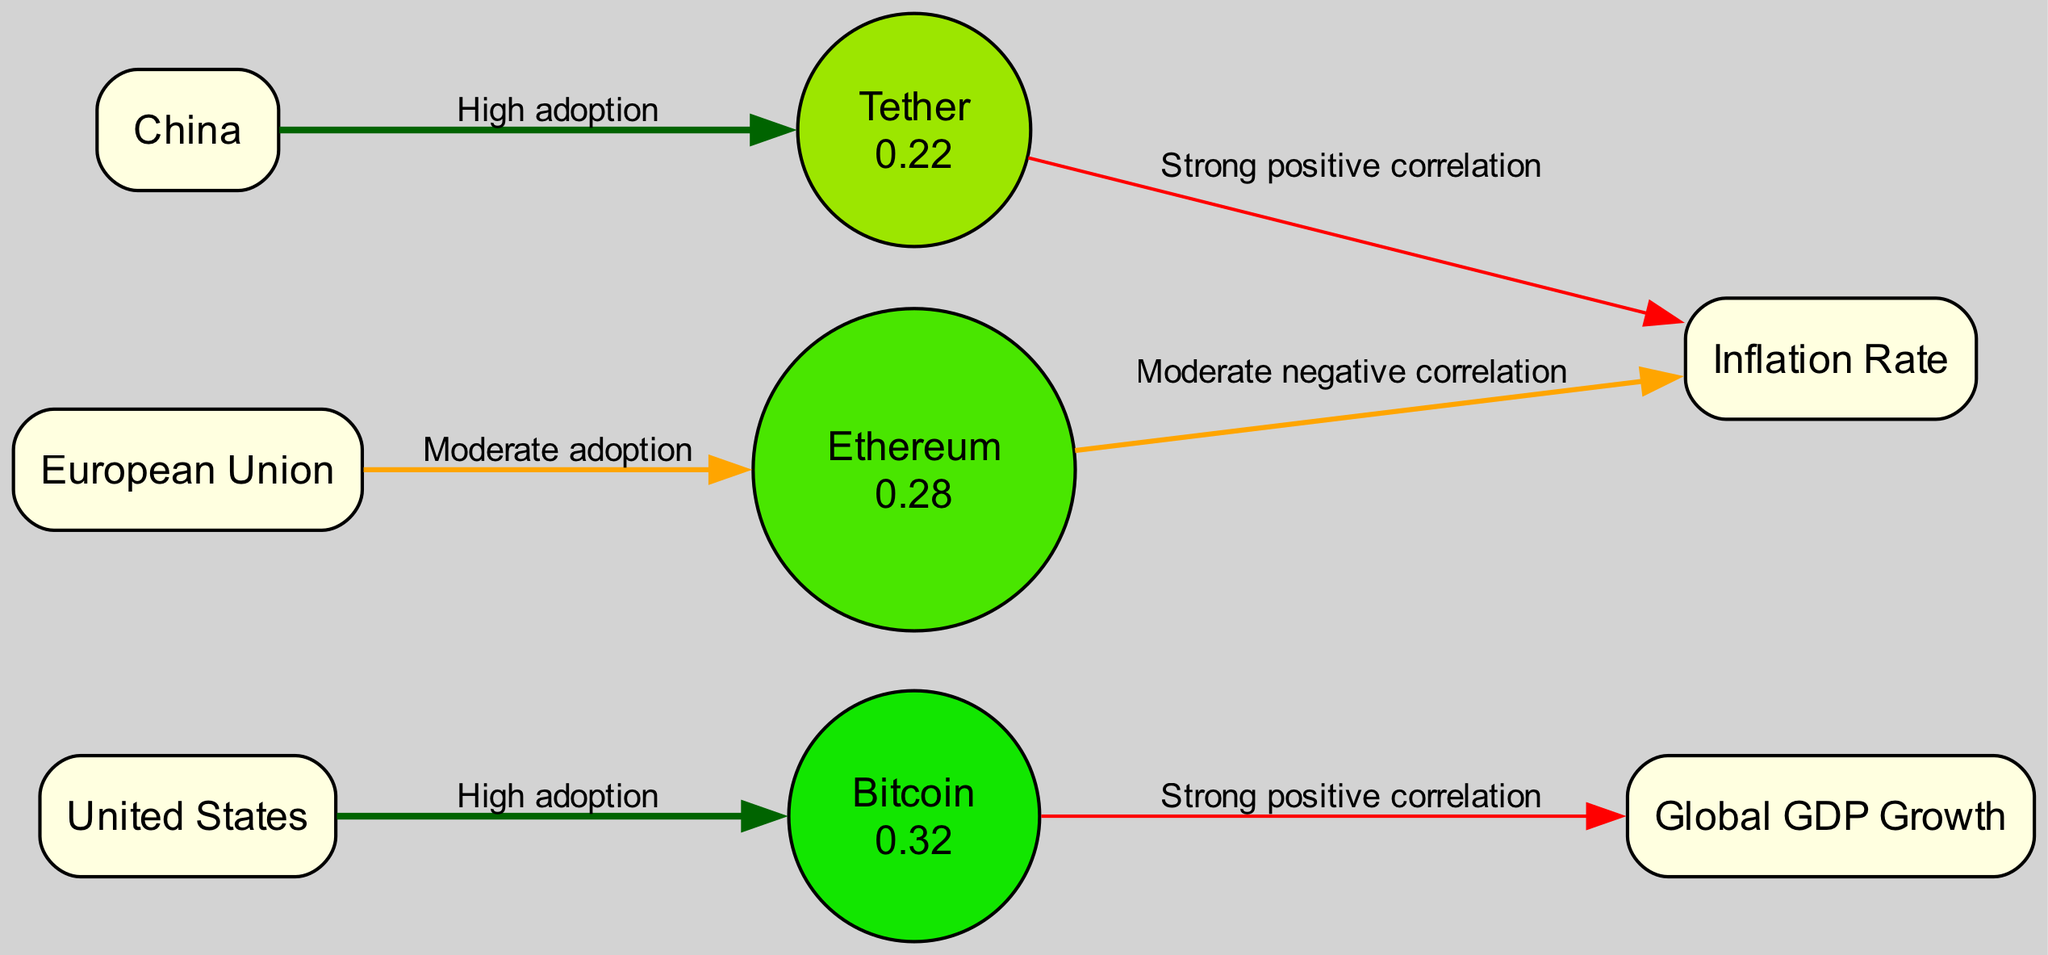What is the adoption rate of Bitcoin? The adoption rate for Bitcoin is specified in the node labeled "Bitcoin," which is 0.32.
Answer: 0.32 How many nodes are present in the diagram? By counting the nodes listed in the data, there are a total of 8 nodes: Bitcoin, Ethereum, Tether, Global GDP Growth, Inflation Rate, United States, China, and European Union.
Answer: 8 What type of correlation exists between Bitcoin and Global GDP Growth? The edge from Bitcoin to Global GDP Growth is labeled "Strong positive correlation," indicating a strong relationship in terms of correlation.
Answer: Strong positive correlation Which country shows high adoption of Tether? The edge from China to Tether indicates that China has a high adoption of Tether as it directly connects these two nodes with the specified relationship.
Answer: China What is the correlation type between Ethereum and Inflation Rate? The edge between Ethereum and Inflation Rate is labeled "Moderate negative correlation," which indicates the nature of their relationship in the context of the diagram.
Answer: Moderate negative correlation What color represents nodes with a high adoption rate in the diagram? High adoption rate nodes are represented in dark green due to their specified color coding as per the edges indicating their level of adoption.
Answer: Dark green Which cryptocurrency has the lowest adoption rate? By comparing the adoption rates provided for Bitcoin (0.32), Ethereum (0.28), and Tether (0.22), Tether has the lowest adoption rate at 0.22.
Answer: Tether Which economic indicator is positively correlated with Tether? The edge from Tether to Inflation Rate is labeled "Strong positive correlation," indicating that it is the economic indicator positively related to Tether in this diagram.
Answer: Inflation Rate What is the pen width of the edge representing the relationship between Ethereum and the European Union? The edge from Ethereum to the European Union is labeled "Moderate adoption," which is assigned a pen width of 1.5 based on the correlation indicator in the data.
Answer: 1.5 